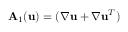<formula> <loc_0><loc_0><loc_500><loc_500>A _ { 1 } ( u ) = ( \boldsymbol \nabla u + \boldsymbol \nabla u ^ { T } )</formula> 